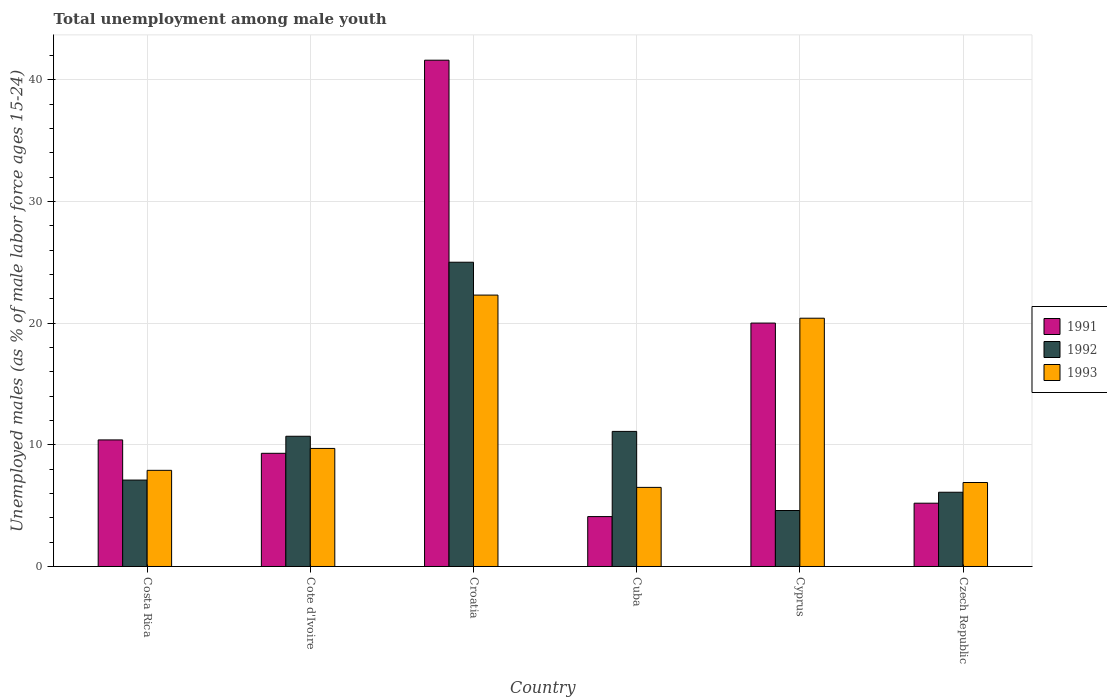How many groups of bars are there?
Offer a terse response. 6. Are the number of bars on each tick of the X-axis equal?
Your response must be concise. Yes. How many bars are there on the 4th tick from the left?
Provide a succinct answer. 3. How many bars are there on the 3rd tick from the right?
Ensure brevity in your answer.  3. What is the label of the 4th group of bars from the left?
Offer a very short reply. Cuba. In how many cases, is the number of bars for a given country not equal to the number of legend labels?
Offer a terse response. 0. What is the percentage of unemployed males in in 1992 in Cote d'Ivoire?
Offer a terse response. 10.7. Across all countries, what is the maximum percentage of unemployed males in in 1993?
Offer a very short reply. 22.3. Across all countries, what is the minimum percentage of unemployed males in in 1992?
Offer a terse response. 4.6. In which country was the percentage of unemployed males in in 1992 maximum?
Your response must be concise. Croatia. In which country was the percentage of unemployed males in in 1991 minimum?
Your answer should be very brief. Cuba. What is the total percentage of unemployed males in in 1993 in the graph?
Your answer should be very brief. 73.7. What is the difference between the percentage of unemployed males in in 1993 in Cyprus and that in Czech Republic?
Ensure brevity in your answer.  13.5. What is the difference between the percentage of unemployed males in in 1993 in Cyprus and the percentage of unemployed males in in 1991 in Croatia?
Keep it short and to the point. -21.2. What is the average percentage of unemployed males in in 1991 per country?
Make the answer very short. 15.1. What is the difference between the percentage of unemployed males in of/in 1992 and percentage of unemployed males in of/in 1993 in Croatia?
Give a very brief answer. 2.7. In how many countries, is the percentage of unemployed males in in 1992 greater than 36 %?
Ensure brevity in your answer.  0. What is the ratio of the percentage of unemployed males in in 1992 in Cyprus to that in Czech Republic?
Provide a succinct answer. 0.75. Is the percentage of unemployed males in in 1992 in Costa Rica less than that in Cyprus?
Keep it short and to the point. No. What is the difference between the highest and the second highest percentage of unemployed males in in 1993?
Make the answer very short. -10.7. What is the difference between the highest and the lowest percentage of unemployed males in in 1991?
Provide a short and direct response. 37.5. Is the sum of the percentage of unemployed males in in 1992 in Costa Rica and Cuba greater than the maximum percentage of unemployed males in in 1993 across all countries?
Ensure brevity in your answer.  No. What does the 1st bar from the left in Costa Rica represents?
Provide a short and direct response. 1991. What does the 1st bar from the right in Cuba represents?
Provide a short and direct response. 1993. Are all the bars in the graph horizontal?
Ensure brevity in your answer.  No. Are the values on the major ticks of Y-axis written in scientific E-notation?
Provide a succinct answer. No. Does the graph contain any zero values?
Make the answer very short. No. Where does the legend appear in the graph?
Make the answer very short. Center right. How many legend labels are there?
Your response must be concise. 3. What is the title of the graph?
Your answer should be compact. Total unemployment among male youth. Does "1991" appear as one of the legend labels in the graph?
Make the answer very short. Yes. What is the label or title of the X-axis?
Make the answer very short. Country. What is the label or title of the Y-axis?
Give a very brief answer. Unemployed males (as % of male labor force ages 15-24). What is the Unemployed males (as % of male labor force ages 15-24) in 1991 in Costa Rica?
Ensure brevity in your answer.  10.4. What is the Unemployed males (as % of male labor force ages 15-24) in 1992 in Costa Rica?
Offer a very short reply. 7.1. What is the Unemployed males (as % of male labor force ages 15-24) of 1993 in Costa Rica?
Your answer should be very brief. 7.9. What is the Unemployed males (as % of male labor force ages 15-24) in 1991 in Cote d'Ivoire?
Your answer should be very brief. 9.3. What is the Unemployed males (as % of male labor force ages 15-24) in 1992 in Cote d'Ivoire?
Ensure brevity in your answer.  10.7. What is the Unemployed males (as % of male labor force ages 15-24) of 1993 in Cote d'Ivoire?
Make the answer very short. 9.7. What is the Unemployed males (as % of male labor force ages 15-24) of 1991 in Croatia?
Provide a short and direct response. 41.6. What is the Unemployed males (as % of male labor force ages 15-24) of 1992 in Croatia?
Provide a short and direct response. 25. What is the Unemployed males (as % of male labor force ages 15-24) of 1993 in Croatia?
Give a very brief answer. 22.3. What is the Unemployed males (as % of male labor force ages 15-24) in 1991 in Cuba?
Offer a very short reply. 4.1. What is the Unemployed males (as % of male labor force ages 15-24) in 1992 in Cuba?
Give a very brief answer. 11.1. What is the Unemployed males (as % of male labor force ages 15-24) in 1992 in Cyprus?
Give a very brief answer. 4.6. What is the Unemployed males (as % of male labor force ages 15-24) in 1993 in Cyprus?
Provide a short and direct response. 20.4. What is the Unemployed males (as % of male labor force ages 15-24) of 1991 in Czech Republic?
Offer a very short reply. 5.2. What is the Unemployed males (as % of male labor force ages 15-24) of 1992 in Czech Republic?
Offer a terse response. 6.1. What is the Unemployed males (as % of male labor force ages 15-24) of 1993 in Czech Republic?
Offer a terse response. 6.9. Across all countries, what is the maximum Unemployed males (as % of male labor force ages 15-24) of 1991?
Make the answer very short. 41.6. Across all countries, what is the maximum Unemployed males (as % of male labor force ages 15-24) of 1992?
Your answer should be compact. 25. Across all countries, what is the maximum Unemployed males (as % of male labor force ages 15-24) of 1993?
Offer a very short reply. 22.3. Across all countries, what is the minimum Unemployed males (as % of male labor force ages 15-24) in 1991?
Provide a short and direct response. 4.1. Across all countries, what is the minimum Unemployed males (as % of male labor force ages 15-24) of 1992?
Make the answer very short. 4.6. Across all countries, what is the minimum Unemployed males (as % of male labor force ages 15-24) in 1993?
Ensure brevity in your answer.  6.5. What is the total Unemployed males (as % of male labor force ages 15-24) in 1991 in the graph?
Provide a short and direct response. 90.6. What is the total Unemployed males (as % of male labor force ages 15-24) of 1992 in the graph?
Give a very brief answer. 64.6. What is the total Unemployed males (as % of male labor force ages 15-24) in 1993 in the graph?
Offer a terse response. 73.7. What is the difference between the Unemployed males (as % of male labor force ages 15-24) in 1991 in Costa Rica and that in Cote d'Ivoire?
Your response must be concise. 1.1. What is the difference between the Unemployed males (as % of male labor force ages 15-24) of 1992 in Costa Rica and that in Cote d'Ivoire?
Ensure brevity in your answer.  -3.6. What is the difference between the Unemployed males (as % of male labor force ages 15-24) of 1993 in Costa Rica and that in Cote d'Ivoire?
Provide a short and direct response. -1.8. What is the difference between the Unemployed males (as % of male labor force ages 15-24) of 1991 in Costa Rica and that in Croatia?
Your answer should be very brief. -31.2. What is the difference between the Unemployed males (as % of male labor force ages 15-24) in 1992 in Costa Rica and that in Croatia?
Offer a terse response. -17.9. What is the difference between the Unemployed males (as % of male labor force ages 15-24) in 1993 in Costa Rica and that in Croatia?
Your answer should be very brief. -14.4. What is the difference between the Unemployed males (as % of male labor force ages 15-24) in 1991 in Costa Rica and that in Cuba?
Offer a terse response. 6.3. What is the difference between the Unemployed males (as % of male labor force ages 15-24) in 1991 in Costa Rica and that in Cyprus?
Your response must be concise. -9.6. What is the difference between the Unemployed males (as % of male labor force ages 15-24) in 1992 in Costa Rica and that in Cyprus?
Ensure brevity in your answer.  2.5. What is the difference between the Unemployed males (as % of male labor force ages 15-24) of 1991 in Costa Rica and that in Czech Republic?
Keep it short and to the point. 5.2. What is the difference between the Unemployed males (as % of male labor force ages 15-24) in 1993 in Costa Rica and that in Czech Republic?
Your answer should be compact. 1. What is the difference between the Unemployed males (as % of male labor force ages 15-24) of 1991 in Cote d'Ivoire and that in Croatia?
Make the answer very short. -32.3. What is the difference between the Unemployed males (as % of male labor force ages 15-24) in 1992 in Cote d'Ivoire and that in Croatia?
Your answer should be very brief. -14.3. What is the difference between the Unemployed males (as % of male labor force ages 15-24) of 1993 in Cote d'Ivoire and that in Croatia?
Ensure brevity in your answer.  -12.6. What is the difference between the Unemployed males (as % of male labor force ages 15-24) in 1991 in Cote d'Ivoire and that in Cuba?
Your answer should be very brief. 5.2. What is the difference between the Unemployed males (as % of male labor force ages 15-24) of 1993 in Cote d'Ivoire and that in Cuba?
Your answer should be very brief. 3.2. What is the difference between the Unemployed males (as % of male labor force ages 15-24) in 1992 in Cote d'Ivoire and that in Cyprus?
Offer a very short reply. 6.1. What is the difference between the Unemployed males (as % of male labor force ages 15-24) in 1991 in Croatia and that in Cuba?
Provide a short and direct response. 37.5. What is the difference between the Unemployed males (as % of male labor force ages 15-24) of 1992 in Croatia and that in Cuba?
Offer a very short reply. 13.9. What is the difference between the Unemployed males (as % of male labor force ages 15-24) of 1993 in Croatia and that in Cuba?
Your answer should be very brief. 15.8. What is the difference between the Unemployed males (as % of male labor force ages 15-24) in 1991 in Croatia and that in Cyprus?
Offer a very short reply. 21.6. What is the difference between the Unemployed males (as % of male labor force ages 15-24) in 1992 in Croatia and that in Cyprus?
Give a very brief answer. 20.4. What is the difference between the Unemployed males (as % of male labor force ages 15-24) of 1993 in Croatia and that in Cyprus?
Provide a succinct answer. 1.9. What is the difference between the Unemployed males (as % of male labor force ages 15-24) of 1991 in Croatia and that in Czech Republic?
Your response must be concise. 36.4. What is the difference between the Unemployed males (as % of male labor force ages 15-24) of 1991 in Cuba and that in Cyprus?
Your answer should be very brief. -15.9. What is the difference between the Unemployed males (as % of male labor force ages 15-24) in 1993 in Cuba and that in Cyprus?
Provide a short and direct response. -13.9. What is the difference between the Unemployed males (as % of male labor force ages 15-24) of 1991 in Cuba and that in Czech Republic?
Your answer should be very brief. -1.1. What is the difference between the Unemployed males (as % of male labor force ages 15-24) in 1993 in Cuba and that in Czech Republic?
Provide a short and direct response. -0.4. What is the difference between the Unemployed males (as % of male labor force ages 15-24) of 1991 in Cyprus and that in Czech Republic?
Your answer should be very brief. 14.8. What is the difference between the Unemployed males (as % of male labor force ages 15-24) of 1992 in Cyprus and that in Czech Republic?
Give a very brief answer. -1.5. What is the difference between the Unemployed males (as % of male labor force ages 15-24) in 1992 in Costa Rica and the Unemployed males (as % of male labor force ages 15-24) in 1993 in Cote d'Ivoire?
Offer a very short reply. -2.6. What is the difference between the Unemployed males (as % of male labor force ages 15-24) of 1991 in Costa Rica and the Unemployed males (as % of male labor force ages 15-24) of 1992 in Croatia?
Offer a terse response. -14.6. What is the difference between the Unemployed males (as % of male labor force ages 15-24) of 1992 in Costa Rica and the Unemployed males (as % of male labor force ages 15-24) of 1993 in Croatia?
Offer a terse response. -15.2. What is the difference between the Unemployed males (as % of male labor force ages 15-24) of 1991 in Costa Rica and the Unemployed males (as % of male labor force ages 15-24) of 1992 in Cuba?
Make the answer very short. -0.7. What is the difference between the Unemployed males (as % of male labor force ages 15-24) in 1991 in Costa Rica and the Unemployed males (as % of male labor force ages 15-24) in 1992 in Czech Republic?
Make the answer very short. 4.3. What is the difference between the Unemployed males (as % of male labor force ages 15-24) of 1991 in Costa Rica and the Unemployed males (as % of male labor force ages 15-24) of 1993 in Czech Republic?
Provide a succinct answer. 3.5. What is the difference between the Unemployed males (as % of male labor force ages 15-24) of 1992 in Costa Rica and the Unemployed males (as % of male labor force ages 15-24) of 1993 in Czech Republic?
Your answer should be very brief. 0.2. What is the difference between the Unemployed males (as % of male labor force ages 15-24) of 1991 in Cote d'Ivoire and the Unemployed males (as % of male labor force ages 15-24) of 1992 in Croatia?
Ensure brevity in your answer.  -15.7. What is the difference between the Unemployed males (as % of male labor force ages 15-24) of 1991 in Cote d'Ivoire and the Unemployed males (as % of male labor force ages 15-24) of 1992 in Cuba?
Ensure brevity in your answer.  -1.8. What is the difference between the Unemployed males (as % of male labor force ages 15-24) in 1991 in Cote d'Ivoire and the Unemployed males (as % of male labor force ages 15-24) in 1992 in Cyprus?
Keep it short and to the point. 4.7. What is the difference between the Unemployed males (as % of male labor force ages 15-24) of 1991 in Cote d'Ivoire and the Unemployed males (as % of male labor force ages 15-24) of 1993 in Czech Republic?
Your response must be concise. 2.4. What is the difference between the Unemployed males (as % of male labor force ages 15-24) of 1992 in Cote d'Ivoire and the Unemployed males (as % of male labor force ages 15-24) of 1993 in Czech Republic?
Keep it short and to the point. 3.8. What is the difference between the Unemployed males (as % of male labor force ages 15-24) in 1991 in Croatia and the Unemployed males (as % of male labor force ages 15-24) in 1992 in Cuba?
Provide a short and direct response. 30.5. What is the difference between the Unemployed males (as % of male labor force ages 15-24) of 1991 in Croatia and the Unemployed males (as % of male labor force ages 15-24) of 1993 in Cuba?
Your answer should be compact. 35.1. What is the difference between the Unemployed males (as % of male labor force ages 15-24) in 1991 in Croatia and the Unemployed males (as % of male labor force ages 15-24) in 1992 in Cyprus?
Your response must be concise. 37. What is the difference between the Unemployed males (as % of male labor force ages 15-24) of 1991 in Croatia and the Unemployed males (as % of male labor force ages 15-24) of 1993 in Cyprus?
Keep it short and to the point. 21.2. What is the difference between the Unemployed males (as % of male labor force ages 15-24) in 1992 in Croatia and the Unemployed males (as % of male labor force ages 15-24) in 1993 in Cyprus?
Provide a short and direct response. 4.6. What is the difference between the Unemployed males (as % of male labor force ages 15-24) in 1991 in Croatia and the Unemployed males (as % of male labor force ages 15-24) in 1992 in Czech Republic?
Ensure brevity in your answer.  35.5. What is the difference between the Unemployed males (as % of male labor force ages 15-24) of 1991 in Croatia and the Unemployed males (as % of male labor force ages 15-24) of 1993 in Czech Republic?
Make the answer very short. 34.7. What is the difference between the Unemployed males (as % of male labor force ages 15-24) in 1992 in Croatia and the Unemployed males (as % of male labor force ages 15-24) in 1993 in Czech Republic?
Your answer should be very brief. 18.1. What is the difference between the Unemployed males (as % of male labor force ages 15-24) of 1991 in Cuba and the Unemployed males (as % of male labor force ages 15-24) of 1993 in Cyprus?
Your answer should be very brief. -16.3. What is the difference between the Unemployed males (as % of male labor force ages 15-24) of 1991 in Cuba and the Unemployed males (as % of male labor force ages 15-24) of 1992 in Czech Republic?
Your response must be concise. -2. What is the difference between the Unemployed males (as % of male labor force ages 15-24) of 1991 in Cuba and the Unemployed males (as % of male labor force ages 15-24) of 1993 in Czech Republic?
Provide a succinct answer. -2.8. What is the difference between the Unemployed males (as % of male labor force ages 15-24) in 1992 in Cuba and the Unemployed males (as % of male labor force ages 15-24) in 1993 in Czech Republic?
Ensure brevity in your answer.  4.2. What is the difference between the Unemployed males (as % of male labor force ages 15-24) of 1992 in Cyprus and the Unemployed males (as % of male labor force ages 15-24) of 1993 in Czech Republic?
Give a very brief answer. -2.3. What is the average Unemployed males (as % of male labor force ages 15-24) of 1991 per country?
Offer a terse response. 15.1. What is the average Unemployed males (as % of male labor force ages 15-24) of 1992 per country?
Give a very brief answer. 10.77. What is the average Unemployed males (as % of male labor force ages 15-24) of 1993 per country?
Your answer should be compact. 12.28. What is the difference between the Unemployed males (as % of male labor force ages 15-24) in 1991 and Unemployed males (as % of male labor force ages 15-24) in 1992 in Costa Rica?
Give a very brief answer. 3.3. What is the difference between the Unemployed males (as % of male labor force ages 15-24) of 1991 and Unemployed males (as % of male labor force ages 15-24) of 1992 in Cote d'Ivoire?
Provide a succinct answer. -1.4. What is the difference between the Unemployed males (as % of male labor force ages 15-24) in 1991 and Unemployed males (as % of male labor force ages 15-24) in 1993 in Cote d'Ivoire?
Offer a terse response. -0.4. What is the difference between the Unemployed males (as % of male labor force ages 15-24) in 1992 and Unemployed males (as % of male labor force ages 15-24) in 1993 in Cote d'Ivoire?
Ensure brevity in your answer.  1. What is the difference between the Unemployed males (as % of male labor force ages 15-24) in 1991 and Unemployed males (as % of male labor force ages 15-24) in 1992 in Croatia?
Offer a terse response. 16.6. What is the difference between the Unemployed males (as % of male labor force ages 15-24) of 1991 and Unemployed males (as % of male labor force ages 15-24) of 1993 in Croatia?
Offer a terse response. 19.3. What is the difference between the Unemployed males (as % of male labor force ages 15-24) of 1991 and Unemployed males (as % of male labor force ages 15-24) of 1993 in Cuba?
Offer a terse response. -2.4. What is the difference between the Unemployed males (as % of male labor force ages 15-24) of 1992 and Unemployed males (as % of male labor force ages 15-24) of 1993 in Cuba?
Your answer should be compact. 4.6. What is the difference between the Unemployed males (as % of male labor force ages 15-24) in 1991 and Unemployed males (as % of male labor force ages 15-24) in 1992 in Cyprus?
Keep it short and to the point. 15.4. What is the difference between the Unemployed males (as % of male labor force ages 15-24) of 1992 and Unemployed males (as % of male labor force ages 15-24) of 1993 in Cyprus?
Provide a short and direct response. -15.8. What is the difference between the Unemployed males (as % of male labor force ages 15-24) in 1991 and Unemployed males (as % of male labor force ages 15-24) in 1992 in Czech Republic?
Offer a very short reply. -0.9. What is the ratio of the Unemployed males (as % of male labor force ages 15-24) in 1991 in Costa Rica to that in Cote d'Ivoire?
Your response must be concise. 1.12. What is the ratio of the Unemployed males (as % of male labor force ages 15-24) of 1992 in Costa Rica to that in Cote d'Ivoire?
Keep it short and to the point. 0.66. What is the ratio of the Unemployed males (as % of male labor force ages 15-24) in 1993 in Costa Rica to that in Cote d'Ivoire?
Your answer should be compact. 0.81. What is the ratio of the Unemployed males (as % of male labor force ages 15-24) of 1991 in Costa Rica to that in Croatia?
Your answer should be very brief. 0.25. What is the ratio of the Unemployed males (as % of male labor force ages 15-24) in 1992 in Costa Rica to that in Croatia?
Keep it short and to the point. 0.28. What is the ratio of the Unemployed males (as % of male labor force ages 15-24) of 1993 in Costa Rica to that in Croatia?
Provide a short and direct response. 0.35. What is the ratio of the Unemployed males (as % of male labor force ages 15-24) in 1991 in Costa Rica to that in Cuba?
Give a very brief answer. 2.54. What is the ratio of the Unemployed males (as % of male labor force ages 15-24) of 1992 in Costa Rica to that in Cuba?
Offer a terse response. 0.64. What is the ratio of the Unemployed males (as % of male labor force ages 15-24) of 1993 in Costa Rica to that in Cuba?
Your answer should be very brief. 1.22. What is the ratio of the Unemployed males (as % of male labor force ages 15-24) in 1991 in Costa Rica to that in Cyprus?
Offer a very short reply. 0.52. What is the ratio of the Unemployed males (as % of male labor force ages 15-24) of 1992 in Costa Rica to that in Cyprus?
Keep it short and to the point. 1.54. What is the ratio of the Unemployed males (as % of male labor force ages 15-24) of 1993 in Costa Rica to that in Cyprus?
Provide a succinct answer. 0.39. What is the ratio of the Unemployed males (as % of male labor force ages 15-24) of 1992 in Costa Rica to that in Czech Republic?
Provide a succinct answer. 1.16. What is the ratio of the Unemployed males (as % of male labor force ages 15-24) of 1993 in Costa Rica to that in Czech Republic?
Provide a succinct answer. 1.14. What is the ratio of the Unemployed males (as % of male labor force ages 15-24) of 1991 in Cote d'Ivoire to that in Croatia?
Ensure brevity in your answer.  0.22. What is the ratio of the Unemployed males (as % of male labor force ages 15-24) of 1992 in Cote d'Ivoire to that in Croatia?
Keep it short and to the point. 0.43. What is the ratio of the Unemployed males (as % of male labor force ages 15-24) in 1993 in Cote d'Ivoire to that in Croatia?
Your answer should be compact. 0.43. What is the ratio of the Unemployed males (as % of male labor force ages 15-24) of 1991 in Cote d'Ivoire to that in Cuba?
Offer a terse response. 2.27. What is the ratio of the Unemployed males (as % of male labor force ages 15-24) in 1992 in Cote d'Ivoire to that in Cuba?
Provide a short and direct response. 0.96. What is the ratio of the Unemployed males (as % of male labor force ages 15-24) in 1993 in Cote d'Ivoire to that in Cuba?
Your response must be concise. 1.49. What is the ratio of the Unemployed males (as % of male labor force ages 15-24) in 1991 in Cote d'Ivoire to that in Cyprus?
Provide a succinct answer. 0.47. What is the ratio of the Unemployed males (as % of male labor force ages 15-24) of 1992 in Cote d'Ivoire to that in Cyprus?
Provide a short and direct response. 2.33. What is the ratio of the Unemployed males (as % of male labor force ages 15-24) in 1993 in Cote d'Ivoire to that in Cyprus?
Give a very brief answer. 0.48. What is the ratio of the Unemployed males (as % of male labor force ages 15-24) in 1991 in Cote d'Ivoire to that in Czech Republic?
Your answer should be compact. 1.79. What is the ratio of the Unemployed males (as % of male labor force ages 15-24) in 1992 in Cote d'Ivoire to that in Czech Republic?
Offer a terse response. 1.75. What is the ratio of the Unemployed males (as % of male labor force ages 15-24) of 1993 in Cote d'Ivoire to that in Czech Republic?
Your answer should be compact. 1.41. What is the ratio of the Unemployed males (as % of male labor force ages 15-24) of 1991 in Croatia to that in Cuba?
Make the answer very short. 10.15. What is the ratio of the Unemployed males (as % of male labor force ages 15-24) of 1992 in Croatia to that in Cuba?
Your response must be concise. 2.25. What is the ratio of the Unemployed males (as % of male labor force ages 15-24) of 1993 in Croatia to that in Cuba?
Your answer should be very brief. 3.43. What is the ratio of the Unemployed males (as % of male labor force ages 15-24) in 1991 in Croatia to that in Cyprus?
Your answer should be very brief. 2.08. What is the ratio of the Unemployed males (as % of male labor force ages 15-24) of 1992 in Croatia to that in Cyprus?
Ensure brevity in your answer.  5.43. What is the ratio of the Unemployed males (as % of male labor force ages 15-24) in 1993 in Croatia to that in Cyprus?
Make the answer very short. 1.09. What is the ratio of the Unemployed males (as % of male labor force ages 15-24) in 1991 in Croatia to that in Czech Republic?
Offer a terse response. 8. What is the ratio of the Unemployed males (as % of male labor force ages 15-24) in 1992 in Croatia to that in Czech Republic?
Offer a terse response. 4.1. What is the ratio of the Unemployed males (as % of male labor force ages 15-24) of 1993 in Croatia to that in Czech Republic?
Your response must be concise. 3.23. What is the ratio of the Unemployed males (as % of male labor force ages 15-24) of 1991 in Cuba to that in Cyprus?
Your answer should be very brief. 0.2. What is the ratio of the Unemployed males (as % of male labor force ages 15-24) in 1992 in Cuba to that in Cyprus?
Ensure brevity in your answer.  2.41. What is the ratio of the Unemployed males (as % of male labor force ages 15-24) of 1993 in Cuba to that in Cyprus?
Your answer should be compact. 0.32. What is the ratio of the Unemployed males (as % of male labor force ages 15-24) of 1991 in Cuba to that in Czech Republic?
Your answer should be compact. 0.79. What is the ratio of the Unemployed males (as % of male labor force ages 15-24) of 1992 in Cuba to that in Czech Republic?
Your answer should be compact. 1.82. What is the ratio of the Unemployed males (as % of male labor force ages 15-24) of 1993 in Cuba to that in Czech Republic?
Your answer should be very brief. 0.94. What is the ratio of the Unemployed males (as % of male labor force ages 15-24) in 1991 in Cyprus to that in Czech Republic?
Your answer should be very brief. 3.85. What is the ratio of the Unemployed males (as % of male labor force ages 15-24) in 1992 in Cyprus to that in Czech Republic?
Provide a succinct answer. 0.75. What is the ratio of the Unemployed males (as % of male labor force ages 15-24) in 1993 in Cyprus to that in Czech Republic?
Offer a terse response. 2.96. What is the difference between the highest and the second highest Unemployed males (as % of male labor force ages 15-24) of 1991?
Ensure brevity in your answer.  21.6. What is the difference between the highest and the second highest Unemployed males (as % of male labor force ages 15-24) of 1992?
Ensure brevity in your answer.  13.9. What is the difference between the highest and the second highest Unemployed males (as % of male labor force ages 15-24) of 1993?
Your response must be concise. 1.9. What is the difference between the highest and the lowest Unemployed males (as % of male labor force ages 15-24) in 1991?
Provide a succinct answer. 37.5. What is the difference between the highest and the lowest Unemployed males (as % of male labor force ages 15-24) in 1992?
Your answer should be compact. 20.4. 